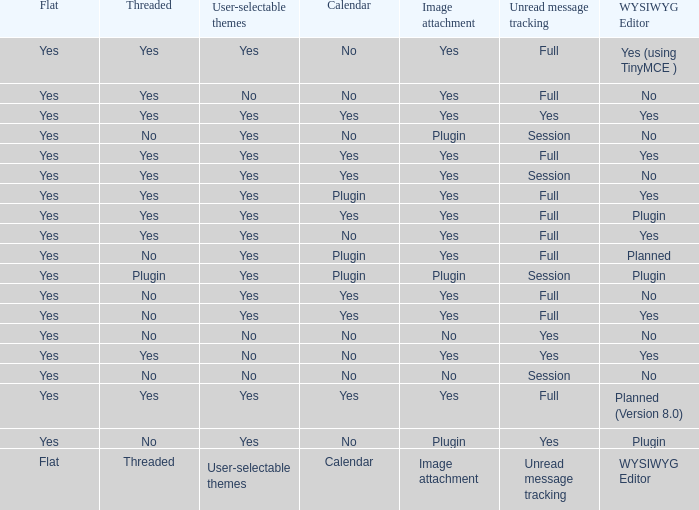Which WYSIWYG Editor has an Image attachment of yes, and a Calendar of plugin? Yes, Planned. 